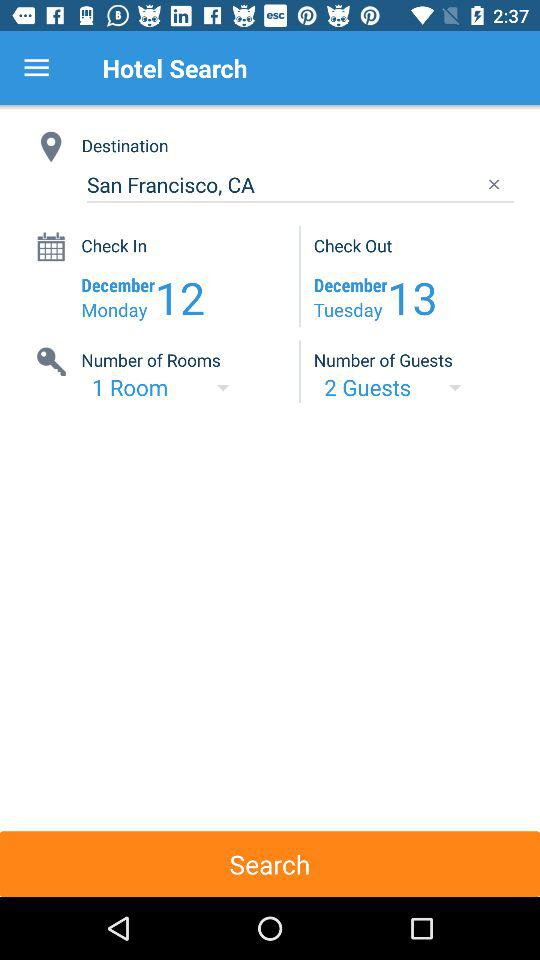How many more guests are there than rooms?
Answer the question using a single word or phrase. 1 